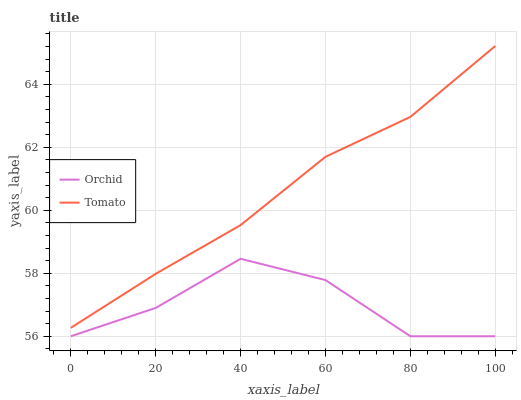Does Orchid have the minimum area under the curve?
Answer yes or no. Yes. Does Tomato have the maximum area under the curve?
Answer yes or no. Yes. Does Orchid have the maximum area under the curve?
Answer yes or no. No. Is Tomato the smoothest?
Answer yes or no. Yes. Is Orchid the roughest?
Answer yes or no. Yes. Is Orchid the smoothest?
Answer yes or no. No. Does Orchid have the lowest value?
Answer yes or no. Yes. Does Tomato have the highest value?
Answer yes or no. Yes. Does Orchid have the highest value?
Answer yes or no. No. Is Orchid less than Tomato?
Answer yes or no. Yes. Is Tomato greater than Orchid?
Answer yes or no. Yes. Does Orchid intersect Tomato?
Answer yes or no. No. 